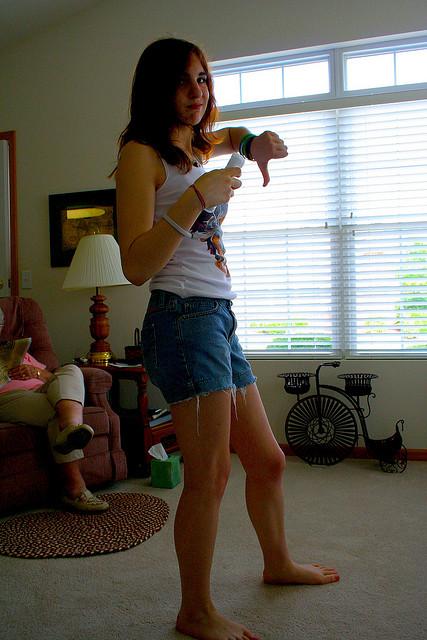Is she playing a game?
Short answer required. Yes. Is this a boy or a girl?
Quick response, please. Girl. Is there another person in this photo?
Short answer required. Yes. 